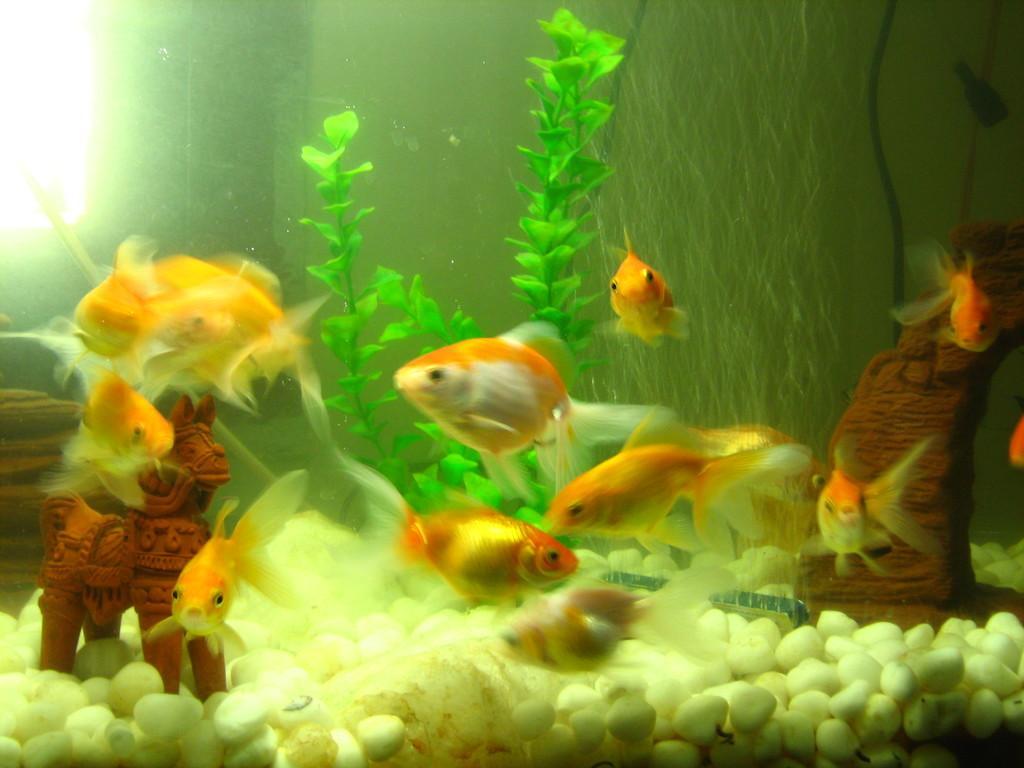Could you give a brief overview of what you see in this image? There are fishes, a plant, a toy, and white color stones in an aquarium. In the top left corner, there is a light. 